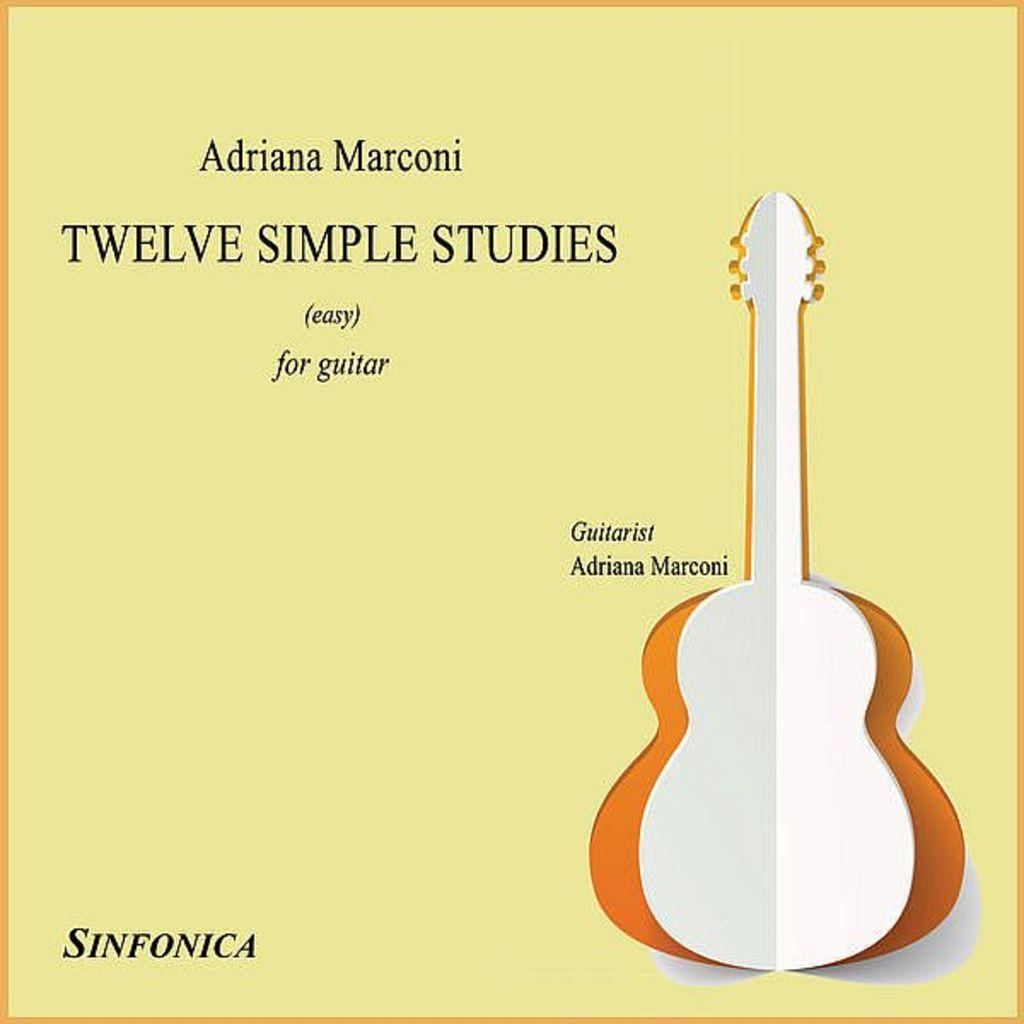What type of image is being described? The image is a poster. What is the main subject of the poster? There is a guitar depicted on the poster. Are there any words or phrases on the poster? Yes, there is text written on the poster. How does the guitar act in the poster? The guitar does not act in the poster, as it is an inanimate object. Can you see a rake in the poster? No, there is no rake present in the poster. 